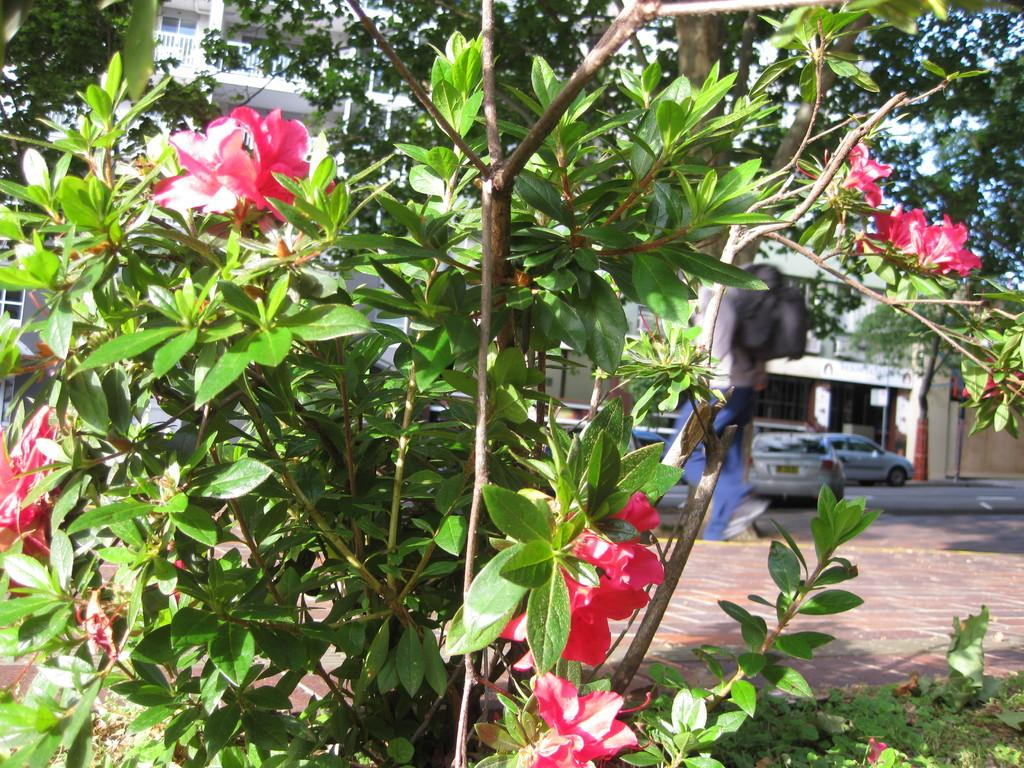What type of plant can be seen in the image? There is a plant with flowers in the image. What can be seen in the distance behind the plant? Cars and buildings are visible in the background of the image. What type of square is being traded in the image? There is no square or trade activity depicted in the image; it features a plant with flowers and a background with cars and buildings. 